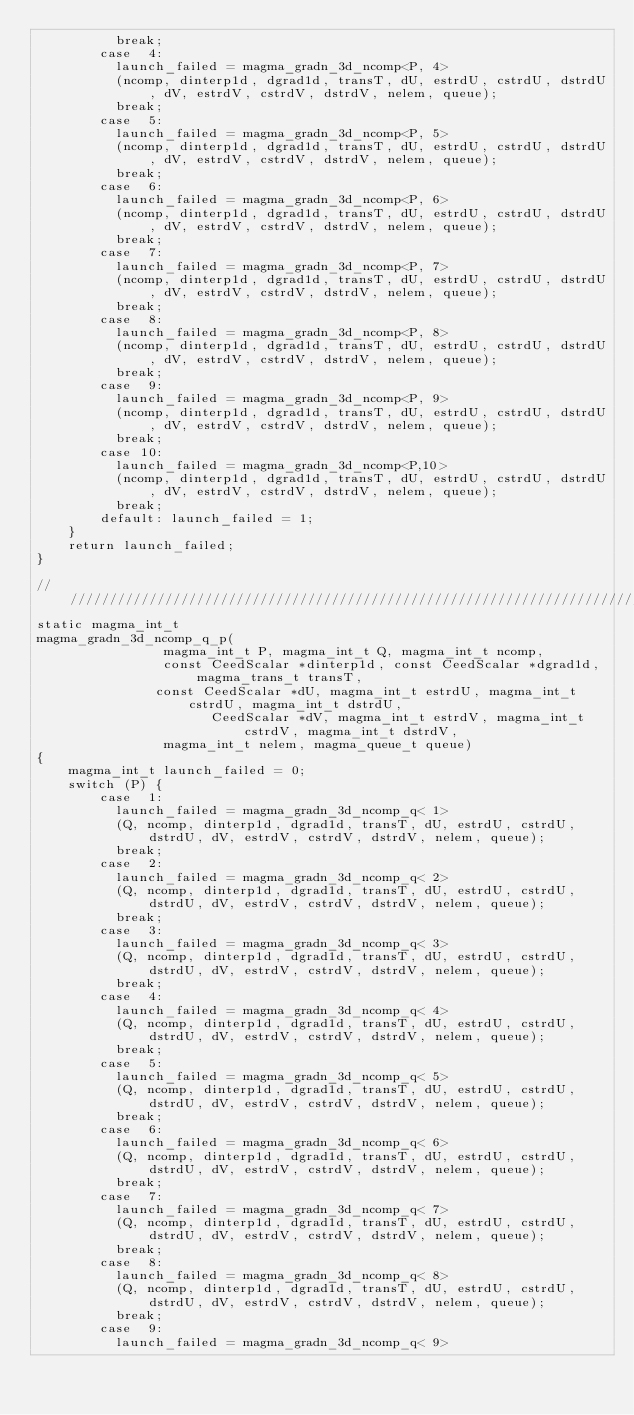<code> <loc_0><loc_0><loc_500><loc_500><_Cuda_>          break;
        case  4: 
          launch_failed = magma_gradn_3d_ncomp<P, 4>
          (ncomp, dinterp1d, dgrad1d, transT, dU, estrdU, cstrdU, dstrdU, dV, estrdV, cstrdV, dstrdV, nelem, queue); 
          break;
        case  5: 
          launch_failed = magma_gradn_3d_ncomp<P, 5>
          (ncomp, dinterp1d, dgrad1d, transT, dU, estrdU, cstrdU, dstrdU, dV, estrdV, cstrdV, dstrdV, nelem, queue); 
          break;
        case  6: 
          launch_failed = magma_gradn_3d_ncomp<P, 6>
          (ncomp, dinterp1d, dgrad1d, transT, dU, estrdU, cstrdU, dstrdU, dV, estrdV, cstrdV, dstrdV, nelem, queue); 
          break;
        case  7: 
          launch_failed = magma_gradn_3d_ncomp<P, 7>
          (ncomp, dinterp1d, dgrad1d, transT, dU, estrdU, cstrdU, dstrdU, dV, estrdV, cstrdV, dstrdV, nelem, queue); 
          break;
        case  8: 
          launch_failed = magma_gradn_3d_ncomp<P, 8>
          (ncomp, dinterp1d, dgrad1d, transT, dU, estrdU, cstrdU, dstrdU, dV, estrdV, cstrdV, dstrdV, nelem, queue); 
          break;
        case  9: 
          launch_failed = magma_gradn_3d_ncomp<P, 9>
          (ncomp, dinterp1d, dgrad1d, transT, dU, estrdU, cstrdU, dstrdU, dV, estrdV, cstrdV, dstrdV, nelem, queue); 
          break;
        case 10: 
          launch_failed = magma_gradn_3d_ncomp<P,10>
          (ncomp, dinterp1d, dgrad1d, transT, dU, estrdU, cstrdU, dstrdU, dV, estrdV, cstrdV, dstrdV, nelem, queue); 
          break;
        default: launch_failed = 1;
    }
    return launch_failed;
}

//////////////////////////////////////////////////////////////////////////////////////////
static magma_int_t 
magma_gradn_3d_ncomp_q_p(
                magma_int_t P, magma_int_t Q, magma_int_t ncomp,
                const CeedScalar *dinterp1d, const CeedScalar *dgrad1d, magma_trans_t transT,
               const CeedScalar *dU, magma_int_t estrdU, magma_int_t cstrdU, magma_int_t dstrdU,
                      CeedScalar *dV, magma_int_t estrdV, magma_int_t cstrdV, magma_int_t dstrdV,
                magma_int_t nelem, magma_queue_t queue)
{
    magma_int_t launch_failed = 0;
    switch (P) {
        case  1: 
          launch_failed = magma_gradn_3d_ncomp_q< 1>
          (Q, ncomp, dinterp1d, dgrad1d, transT, dU, estrdU, cstrdU, dstrdU, dV, estrdV, cstrdV, dstrdV, nelem, queue); 
          break;
        case  2: 
          launch_failed = magma_gradn_3d_ncomp_q< 2>
          (Q, ncomp, dinterp1d, dgrad1d, transT, dU, estrdU, cstrdU, dstrdU, dV, estrdV, cstrdV, dstrdV, nelem, queue); 
          break;
        case  3: 
          launch_failed = magma_gradn_3d_ncomp_q< 3>
          (Q, ncomp, dinterp1d, dgrad1d, transT, dU, estrdU, cstrdU, dstrdU, dV, estrdV, cstrdV, dstrdV, nelem, queue); 
          break;
        case  4: 
          launch_failed = magma_gradn_3d_ncomp_q< 4>
          (Q, ncomp, dinterp1d, dgrad1d, transT, dU, estrdU, cstrdU, dstrdU, dV, estrdV, cstrdV, dstrdV, nelem, queue); 
          break;
        case  5: 
          launch_failed = magma_gradn_3d_ncomp_q< 5>
          (Q, ncomp, dinterp1d, dgrad1d, transT, dU, estrdU, cstrdU, dstrdU, dV, estrdV, cstrdV, dstrdV, nelem, queue); 
          break;
        case  6: 
          launch_failed = magma_gradn_3d_ncomp_q< 6>
          (Q, ncomp, dinterp1d, dgrad1d, transT, dU, estrdU, cstrdU, dstrdU, dV, estrdV, cstrdV, dstrdV, nelem, queue); 
          break;
        case  7: 
          launch_failed = magma_gradn_3d_ncomp_q< 7>
          (Q, ncomp, dinterp1d, dgrad1d, transT, dU, estrdU, cstrdU, dstrdU, dV, estrdV, cstrdV, dstrdV, nelem, queue); 
          break;
        case  8: 
          launch_failed = magma_gradn_3d_ncomp_q< 8>
          (Q, ncomp, dinterp1d, dgrad1d, transT, dU, estrdU, cstrdU, dstrdU, dV, estrdV, cstrdV, dstrdV, nelem, queue); 
          break;
        case  9: 
          launch_failed = magma_gradn_3d_ncomp_q< 9></code> 